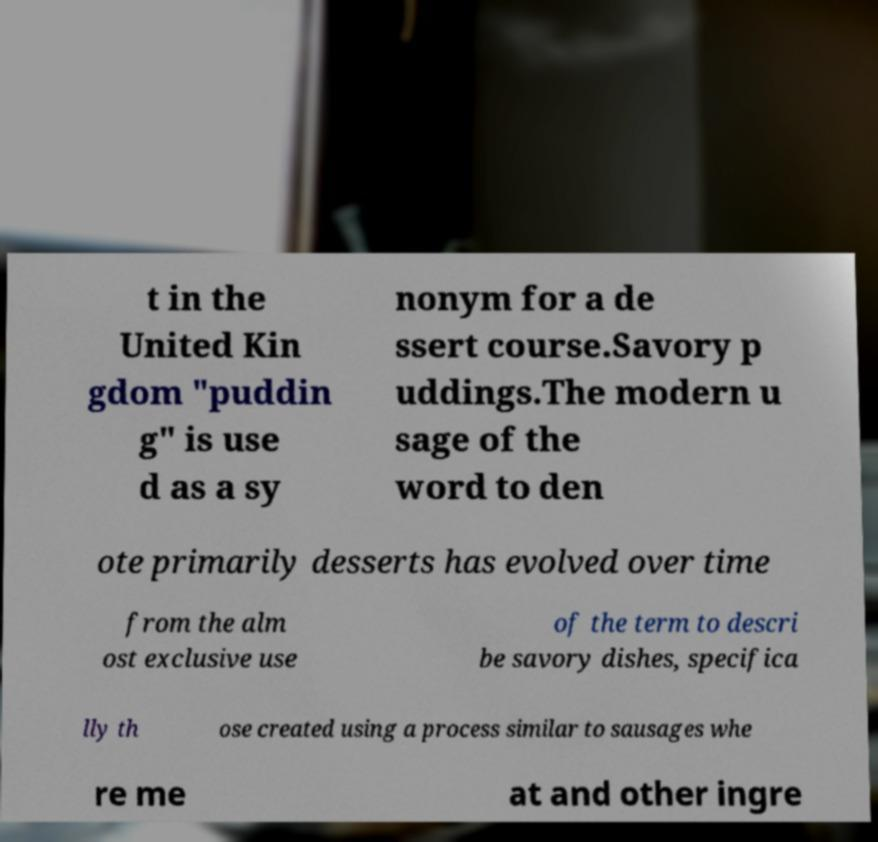Could you assist in decoding the text presented in this image and type it out clearly? t in the United Kin gdom "puddin g" is use d as a sy nonym for a de ssert course.Savory p uddings.The modern u sage of the word to den ote primarily desserts has evolved over time from the alm ost exclusive use of the term to descri be savory dishes, specifica lly th ose created using a process similar to sausages whe re me at and other ingre 